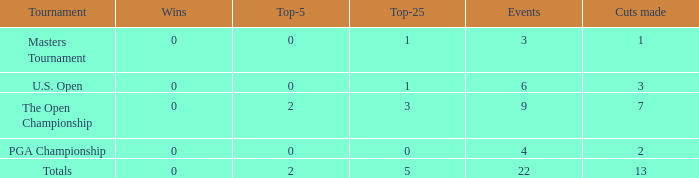What is the total number of wins for events with under 2 top-5s, under 5 top-25s, and more than 4 events played? 1.0. 